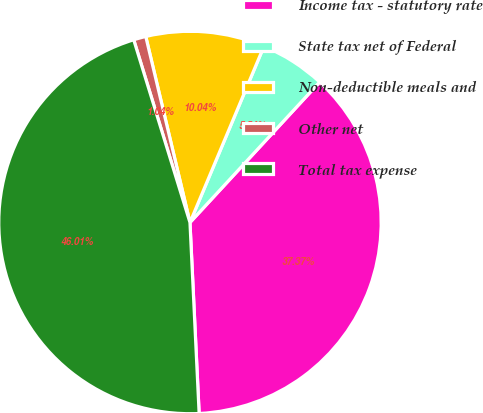Convert chart to OTSL. <chart><loc_0><loc_0><loc_500><loc_500><pie_chart><fcel>Income tax - statutory rate<fcel>State tax net of Federal<fcel>Non-deductible meals and<fcel>Other net<fcel>Total tax expense<nl><fcel>37.37%<fcel>5.54%<fcel>10.04%<fcel>1.04%<fcel>46.01%<nl></chart> 